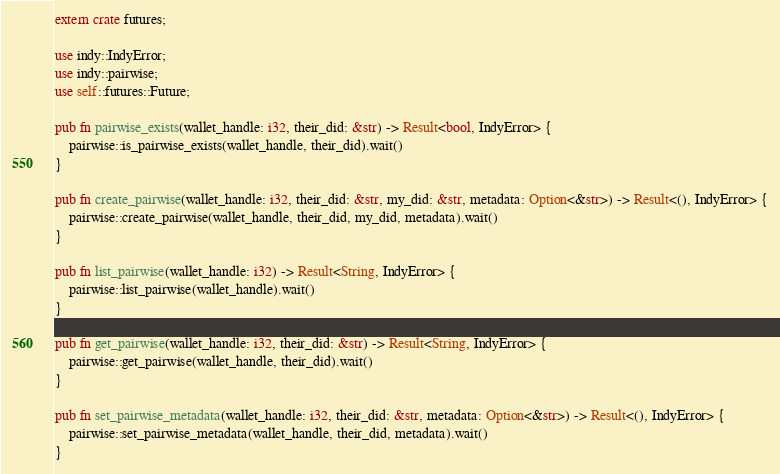Convert code to text. <code><loc_0><loc_0><loc_500><loc_500><_Rust_>extern crate futures;

use indy::IndyError;
use indy::pairwise;
use self::futures::Future;

pub fn pairwise_exists(wallet_handle: i32, their_did: &str) -> Result<bool, IndyError> {
    pairwise::is_pairwise_exists(wallet_handle, their_did).wait()
}

pub fn create_pairwise(wallet_handle: i32, their_did: &str, my_did: &str, metadata: Option<&str>) -> Result<(), IndyError> {
    pairwise::create_pairwise(wallet_handle, their_did, my_did, metadata).wait()
}

pub fn list_pairwise(wallet_handle: i32) -> Result<String, IndyError> {
    pairwise::list_pairwise(wallet_handle).wait()
}

pub fn get_pairwise(wallet_handle: i32, their_did: &str) -> Result<String, IndyError> {
    pairwise::get_pairwise(wallet_handle, their_did).wait()
}

pub fn set_pairwise_metadata(wallet_handle: i32, their_did: &str, metadata: Option<&str>) -> Result<(), IndyError> {
    pairwise::set_pairwise_metadata(wallet_handle, their_did, metadata).wait()
}</code> 